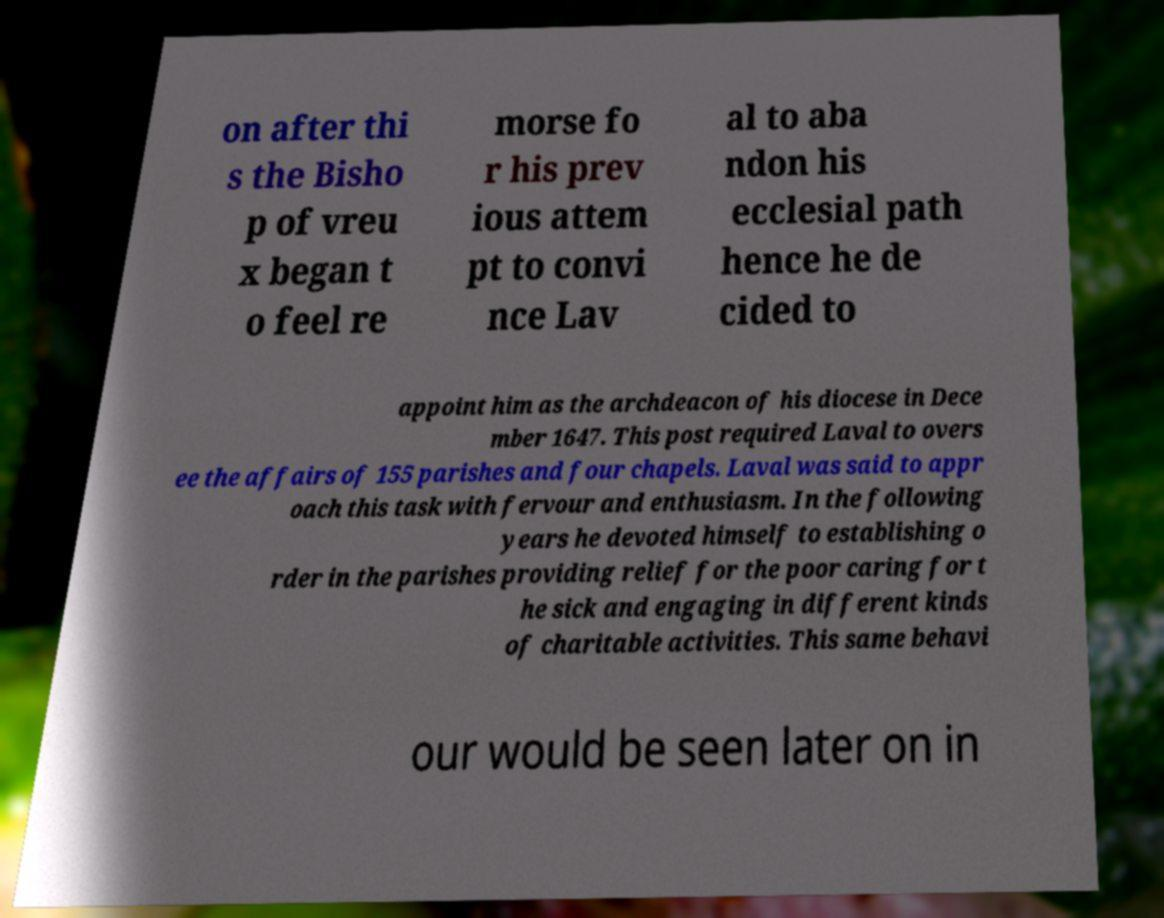For documentation purposes, I need the text within this image transcribed. Could you provide that? on after thi s the Bisho p of vreu x began t o feel re morse fo r his prev ious attem pt to convi nce Lav al to aba ndon his ecclesial path hence he de cided to appoint him as the archdeacon of his diocese in Dece mber 1647. This post required Laval to overs ee the affairs of 155 parishes and four chapels. Laval was said to appr oach this task with fervour and enthusiasm. In the following years he devoted himself to establishing o rder in the parishes providing relief for the poor caring for t he sick and engaging in different kinds of charitable activities. This same behavi our would be seen later on in 